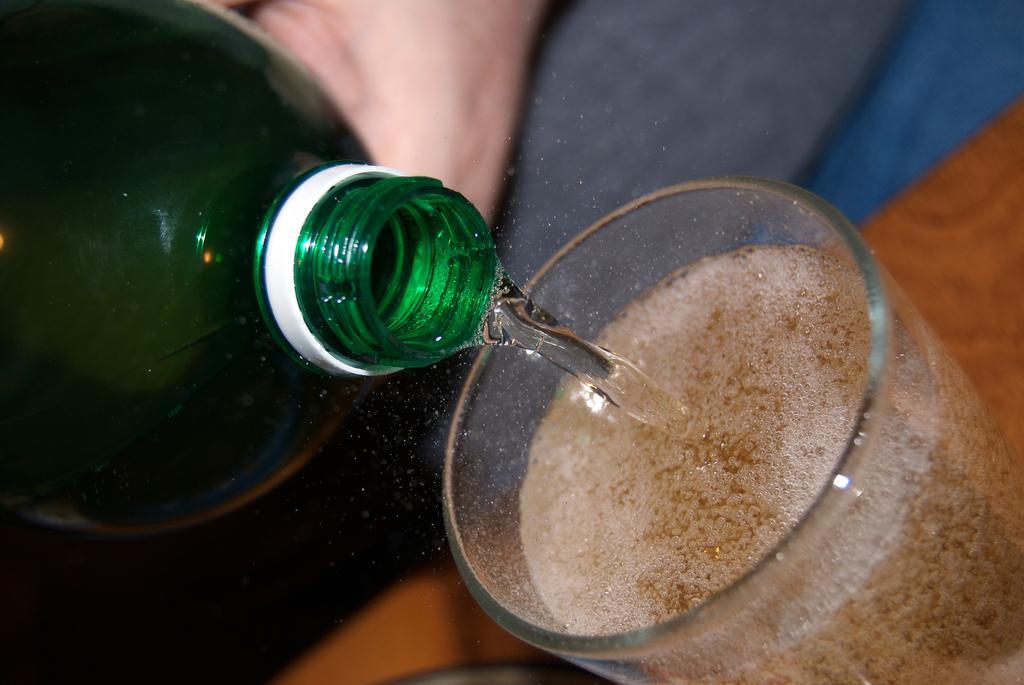Describe this image in one or two sentences. Here we can see a glass on the table, and some drink in it, and here is the bottle and water in it. 